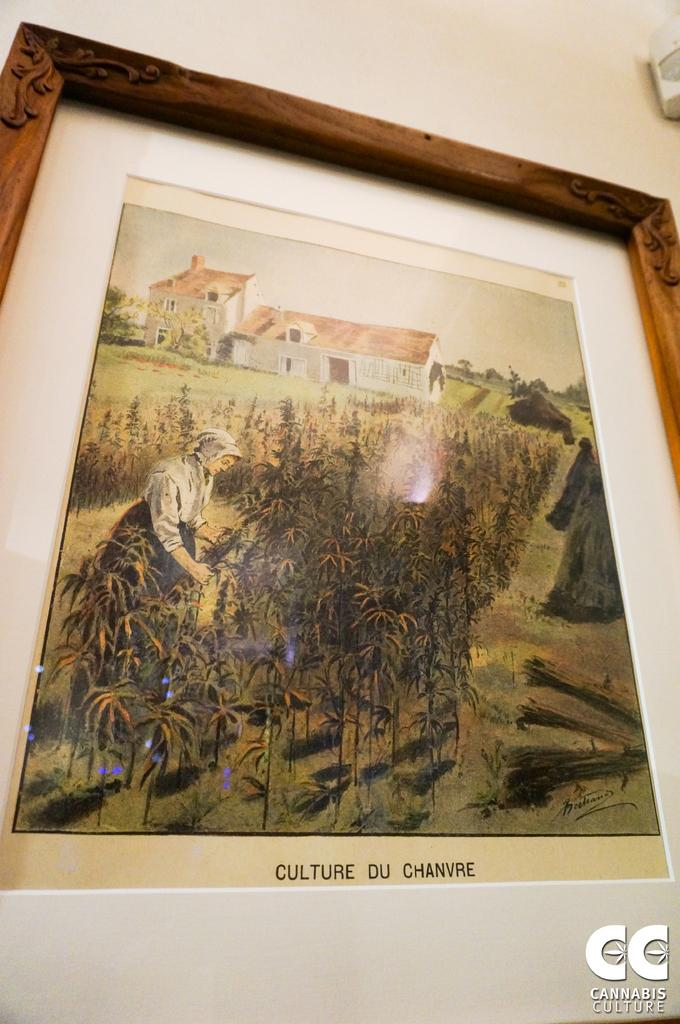<image>
Relay a brief, clear account of the picture shown. A framed picture with the words Culture Du Chanvre as a description below it. 